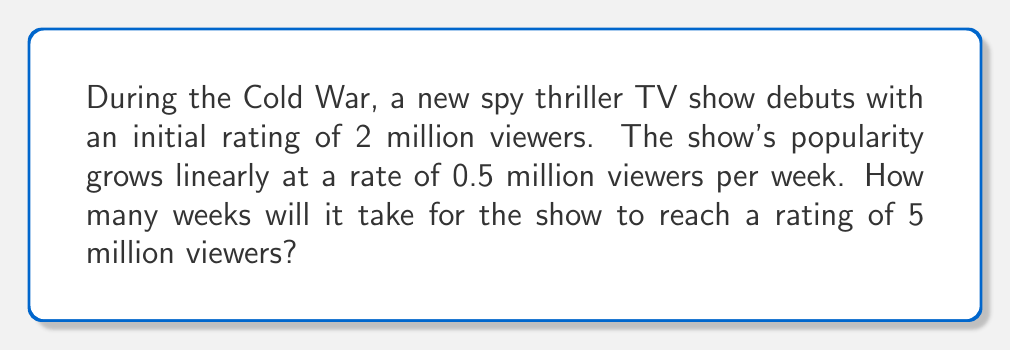Could you help me with this problem? Let's approach this step-by-step using a linear equation:

1) Let $y$ be the number of viewers (in millions) and $x$ be the number of weeks.

2) We can represent the linear growth with the equation:
   $y = mx + b$
   where $m$ is the slope (rate of increase) and $b$ is the y-intercept (initial rating).

3) Given information:
   - Initial rating (b) = 2 million viewers
   - Rate of increase (m) = 0.5 million viewers per week
   - Target rating = 5 million viewers

4) Our equation becomes:
   $y = 0.5x + 2$

5) We want to find $x$ when $y = 5$, so we substitute:
   $5 = 0.5x + 2$

6) Solve for $x$:
   $5 - 2 = 0.5x$
   $3 = 0.5x$
   $x = 3 \div 0.5 = 6$

Therefore, it will take 6 weeks for the show to reach 5 million viewers.
Answer: 6 weeks 